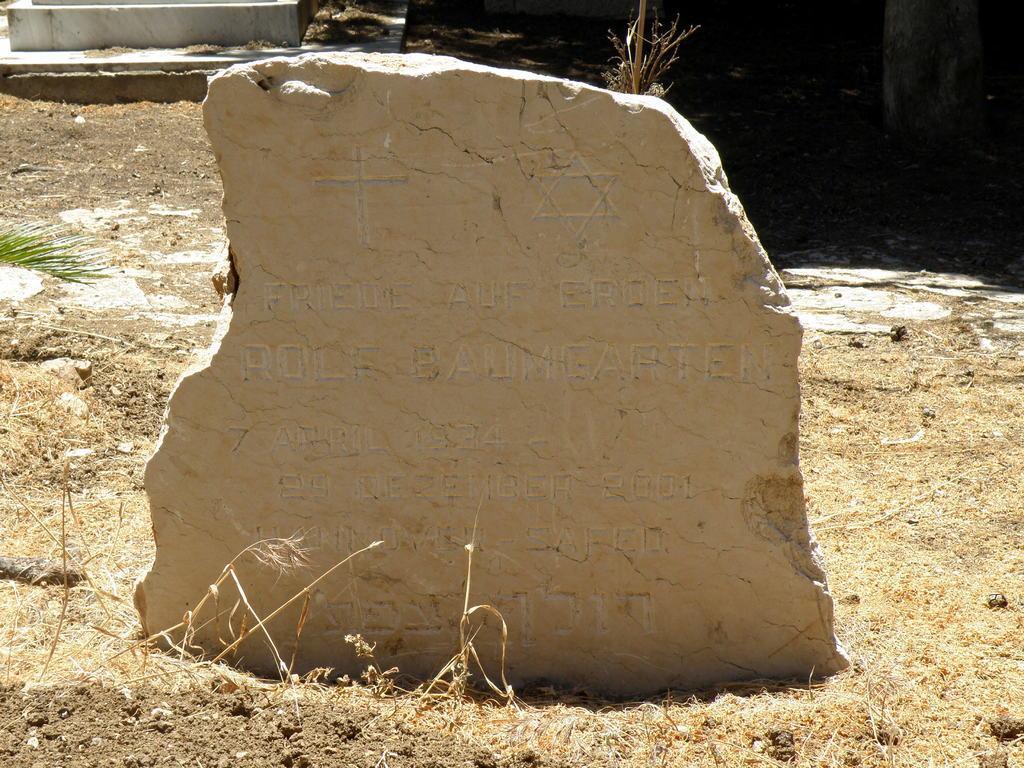Could you give a brief overview of what you see in this image? In this image in the front there is a stone with some text written on it and in the background there is grass, there is a wall and there is a marble stone. 